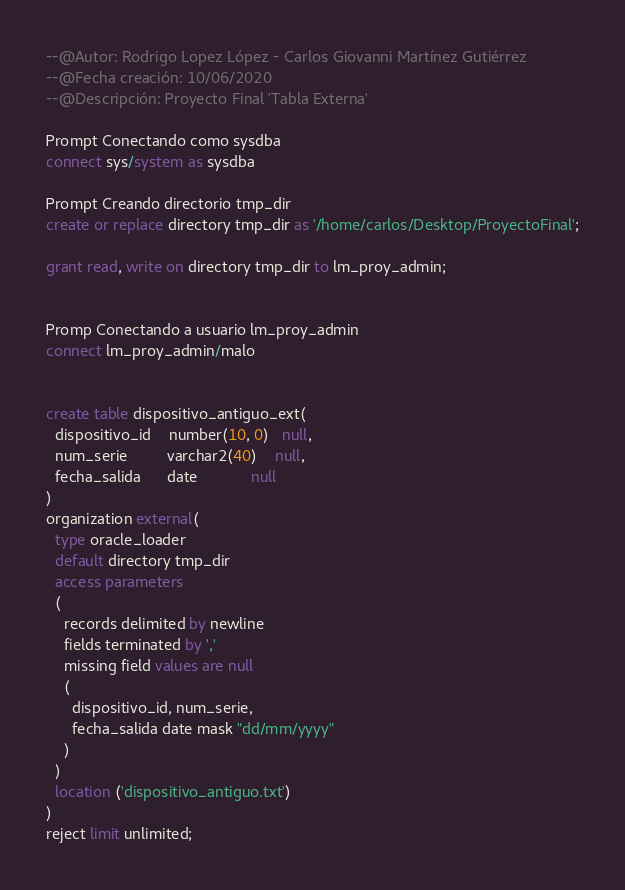<code> <loc_0><loc_0><loc_500><loc_500><_SQL_>--@Autor: Rodrigo Lopez López - Carlos Giovanni Martínez Gutiérrez
--@Fecha creación: 10/06/2020
--@Descripción: Proyecto Final 'Tabla Externa'

Prompt Conectando como sysdba 
connect sys/system as sysdba 

Prompt Creando directorio tmp_dir
create or replace directory tmp_dir as '/home/carlos/Desktop/ProyectoFinal';

grant read, write on directory tmp_dir to lm_proy_admin;


Promp Conectando a usuario lm_proy_admin 
connect lm_proy_admin/malo


create table dispositivo_antiguo_ext(
  dispositivo_id    number(10, 0)   null,
  num_serie         varchar2(40)    null,
  fecha_salida      date            null
)
organization external(
  type oracle_loader
  default directory tmp_dir
  access parameters
  (
    records delimited by newline 
    fields terminated by ','
    missing field values are null
    (
      dispositivo_id, num_serie, 
      fecha_salida date mask "dd/mm/yyyy"
    )
  )
  location ('dispositivo_antiguo.txt')
)
reject limit unlimited;
</code> 